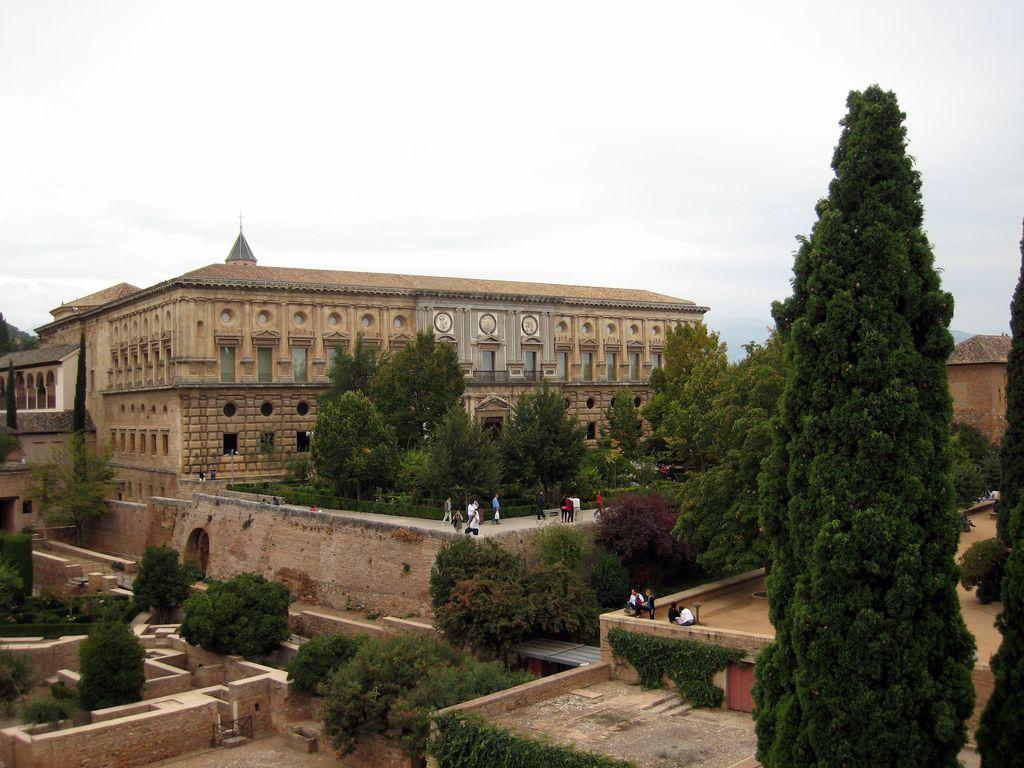Describe this image in one or two sentences. This picture is clicked outside the city. There are many trees. We see people walking in the middle of the picture. Behind them, there is a building which is made up of cobblestones. At the top of the picture, we see the sky. 